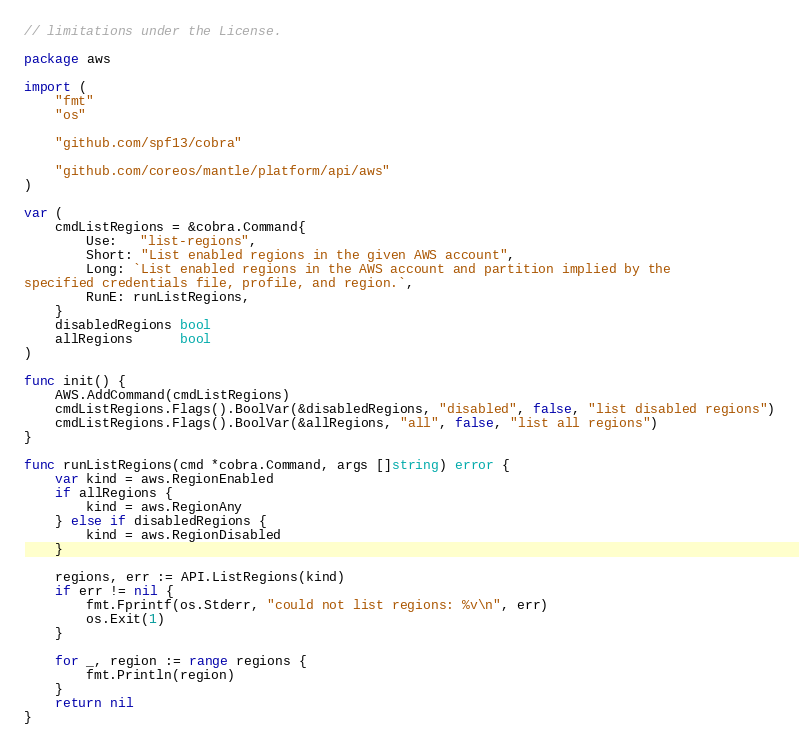Convert code to text. <code><loc_0><loc_0><loc_500><loc_500><_Go_>// limitations under the License.

package aws

import (
	"fmt"
	"os"

	"github.com/spf13/cobra"

	"github.com/coreos/mantle/platform/api/aws"
)

var (
	cmdListRegions = &cobra.Command{
		Use:   "list-regions",
		Short: "List enabled regions in the given AWS account",
		Long: `List enabled regions in the AWS account and partition implied by the
specified credentials file, profile, and region.`,
		RunE: runListRegions,
	}
	disabledRegions bool
	allRegions      bool
)

func init() {
	AWS.AddCommand(cmdListRegions)
	cmdListRegions.Flags().BoolVar(&disabledRegions, "disabled", false, "list disabled regions")
	cmdListRegions.Flags().BoolVar(&allRegions, "all", false, "list all regions")
}

func runListRegions(cmd *cobra.Command, args []string) error {
	var kind = aws.RegionEnabled
	if allRegions {
		kind = aws.RegionAny
	} else if disabledRegions {
		kind = aws.RegionDisabled
	}

	regions, err := API.ListRegions(kind)
	if err != nil {
		fmt.Fprintf(os.Stderr, "could not list regions: %v\n", err)
		os.Exit(1)
	}

	for _, region := range regions {
		fmt.Println(region)
	}
	return nil
}
</code> 